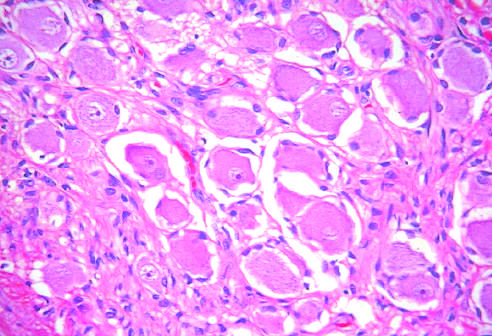what contain mature cells from endodermal, mesodermal, and ectodermal lines?
Answer the question using a single word or phrase. Testicular teratomas 